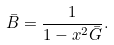Convert formula to latex. <formula><loc_0><loc_0><loc_500><loc_500>\bar { B } = \frac { 1 } { 1 - x ^ { 2 } \bar { G } } .</formula> 